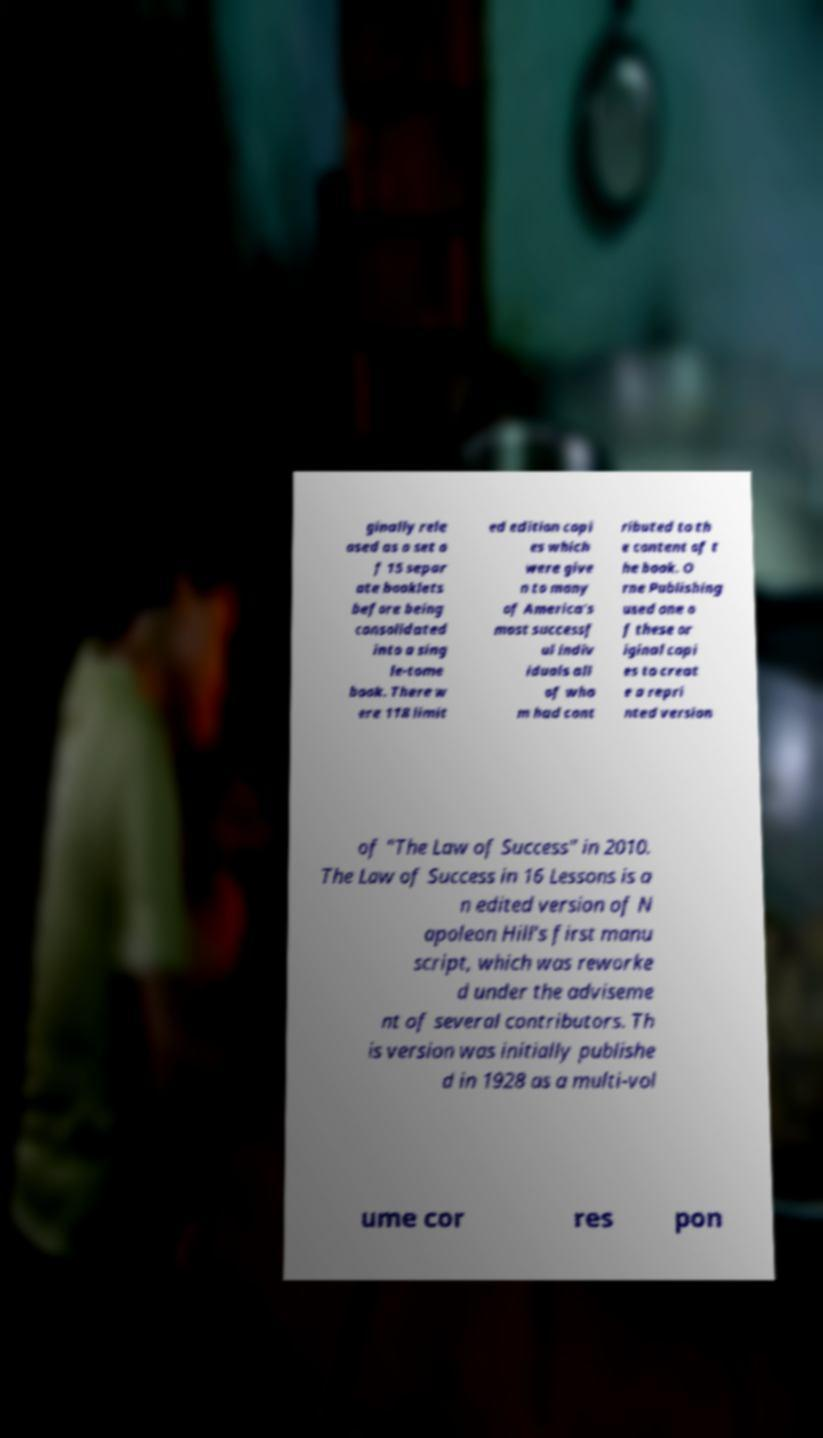What messages or text are displayed in this image? I need them in a readable, typed format. ginally rele ased as a set o f 15 separ ate booklets before being consolidated into a sing le-tome book. There w ere 118 limit ed edition copi es which were give n to many of America's most successf ul indiv iduals all of who m had cont ributed to th e content of t he book. O rne Publishing used one o f these or iginal copi es to creat e a repri nted version of "The Law of Success" in 2010. The Law of Success in 16 Lessons is a n edited version of N apoleon Hill’s first manu script, which was reworke d under the adviseme nt of several contributors. Th is version was initially publishe d in 1928 as a multi-vol ume cor res pon 